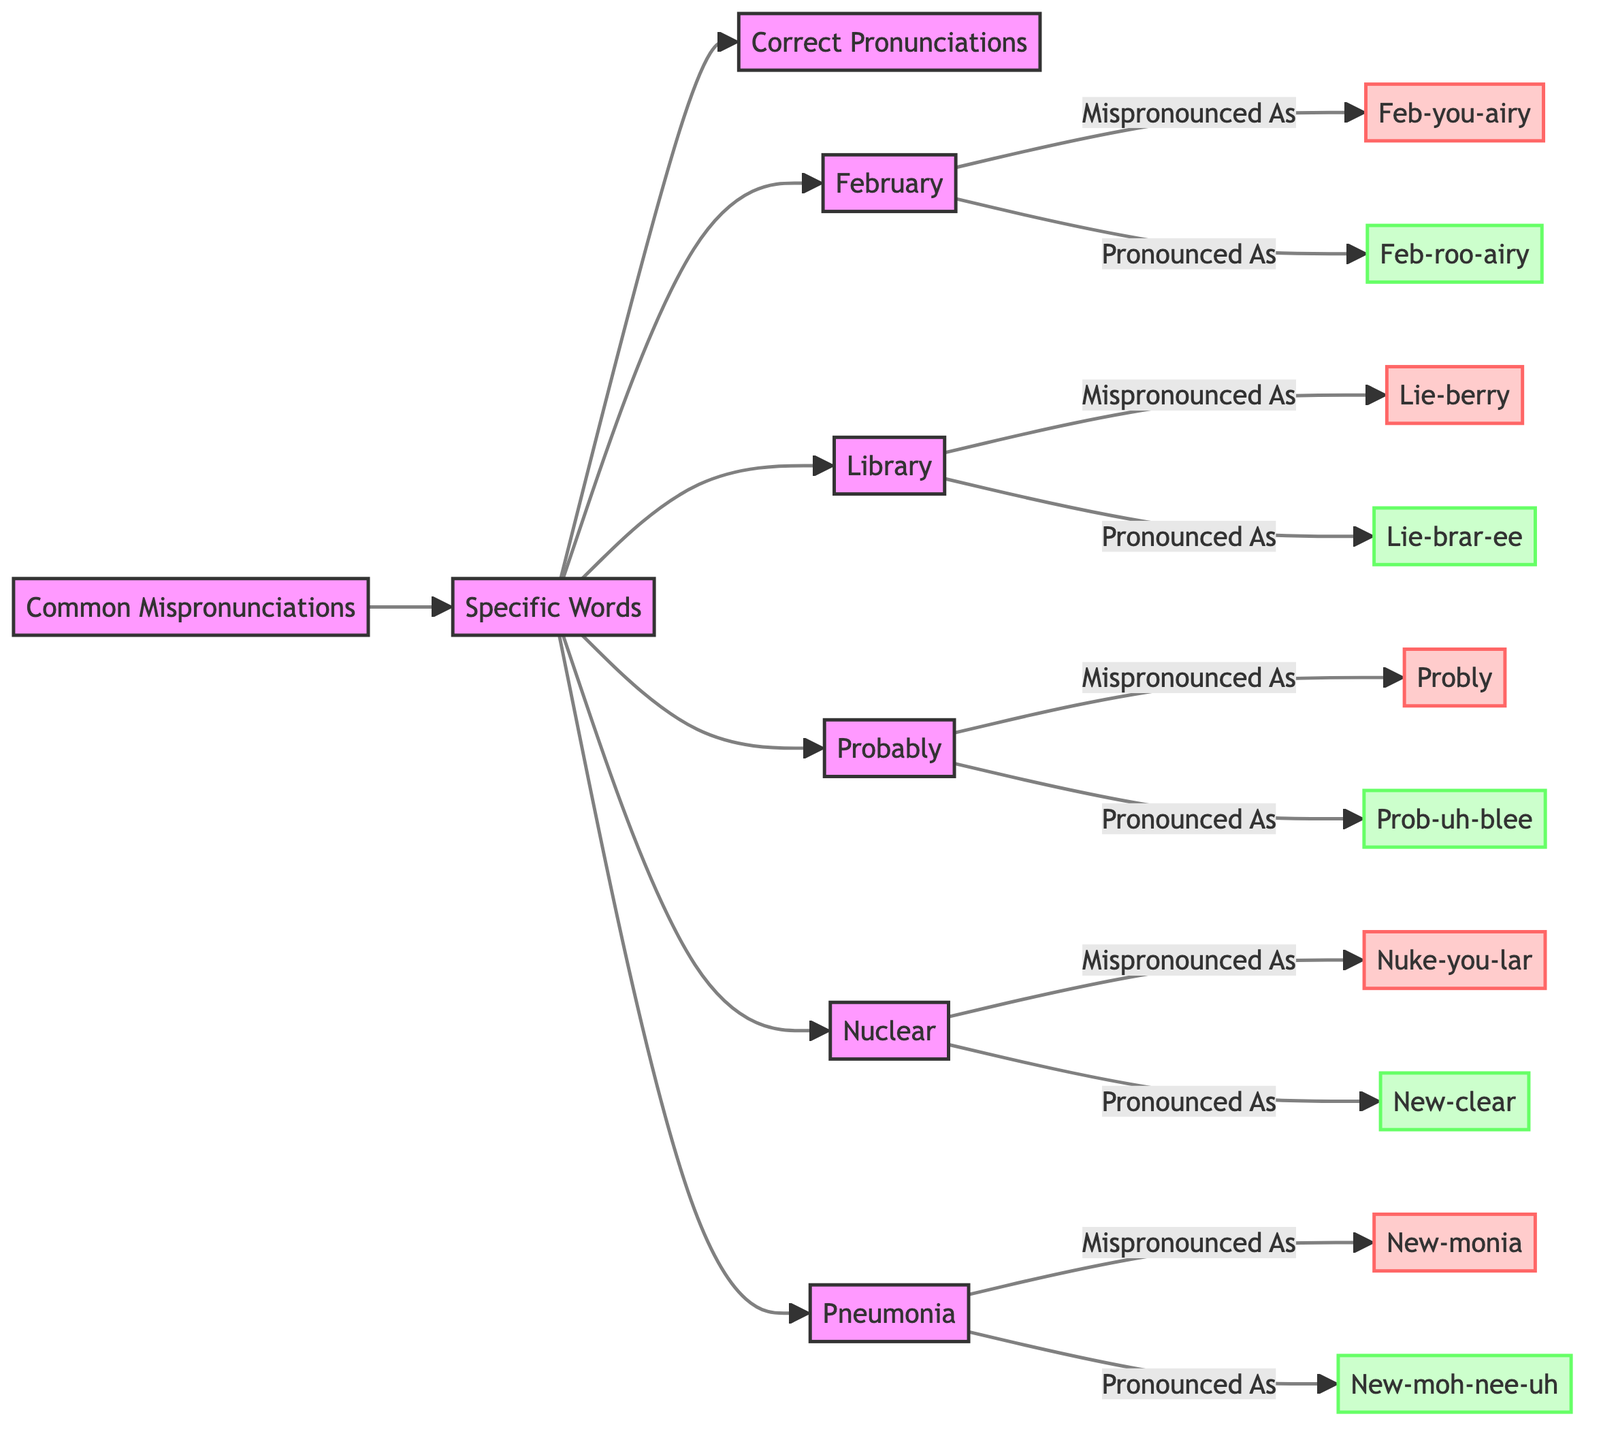What is the first common mispronunciation listed in the diagram? In the diagram, the first specific word listed under common mispronunciations is February. This is directly visible as it is the first word stemming from the node "Specific Words."
Answer: February How many common mispronunciations are shown in the diagram? The diagram presents five common mispronunciations: February, Library, Probably, Nuclear, and Pneumonia. By counting these words, we can determine that there are a total of five.
Answer: 5 What is the correct pronunciation of "Nuclear"? According to the diagram, "Nuclear" is correctly pronounced as "New-clear." This is indicated on the corresponding path from the mispronounced form to its correct form.
Answer: New-clear Which word is mispronounced as "Lie-berry"? The diagram shows that "Library" is the word that is mispronounced as "Lie-berry." This association is explicitly presented in the directed path from "Library" to the mispronunciation node.
Answer: Library What is the relationship between "Probably" and its mispronunciation? The diagram indicates that "Probably" is mispronounced as "Probly." This relationship is shown through a direct edge from "Probably" to its mispronounced version, illustrating the connection between them.
Answer: Probly What is the correct pronunciation of "Pneumonia"? The correct pronunciation of "Pneumonia," as depicted in the diagram, is "New-moh-nee-uh." This information is found directly connected to the mispronounced version "New-monia."
Answer: New-moh-nee-uh Which mispronounced word is associated with the pronunciation "Feb-you-airy"? According to the diagram, the mispronounced form "Feb-you-airy" is associated with the word "February." This connection can be traced from the node "February" to its mispronunciation.
Answer: February How is the word "Library" pronounced correctly according to the diagram? The diagram specifies that "Library" should be pronounced as "Lie-brar-ee." This correct pronunciation can be identified following the arrow from the mispronounced label.
Answer: Lie-brar-ee 